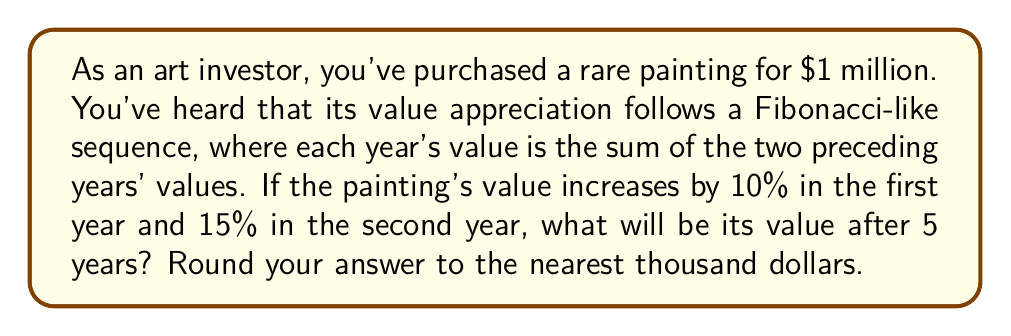What is the answer to this math problem? Let's approach this step-by-step:

1) First, let's calculate the value for the first two years:
   Year 0: $1,000,000 (initial value)
   Year 1: $1,000,000 * 1.10 = $1,100,000
   Year 2: $1,100,000 * 1.15 = $1,265,000

2) Now, we'll use the Fibonacci-like sequence for the next three years:
   Year 3: $1,100,000 + $1,265,000 = $2,365,000
   Year 4: $1,265,000 + $2,365,000 = $3,630,000
   Year 5: $2,365,000 + $3,630,000 = $5,995,000

3) The sequence can be represented mathematically as:

   $$V_n = V_{n-1} + V_{n-2}$$

   Where $V_n$ is the value in year $n$, and $n \ge 3$

4) We can verify our calculations:
   $$V_3 = V_2 + V_1 = 1,265,000 + 1,100,000 = 2,365,000$$
   $$V_4 = V_3 + V_2 = 2,365,000 + 1,265,000 = 3,630,000$$
   $$V_5 = V_4 + V_3 = 3,630,000 + 2,365,000 = 5,995,000$$

5) Rounding to the nearest thousand:
   $5,995,000 \approx 5,995,000$

Therefore, after 5 years, the painting's value will be approximately $5,995,000.
Answer: $5,995,000 